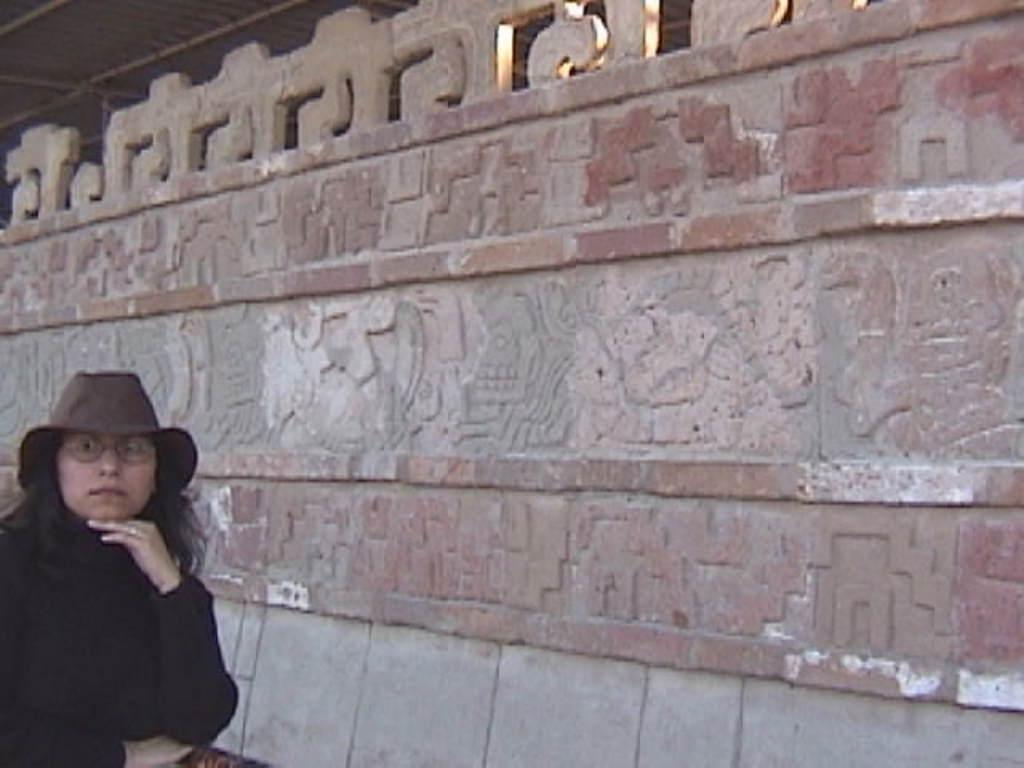Who is present in the image? There is a woman in the image. Where is the woman located in the image? The woman is on the left side of the image. What is the woman wearing on her head? The woman is wearing a hat. What can be seen behind the woman in the image? There is a wall in the image. How is the wall decorated or designed? The wall is carved. How do the dolls show respect to the woman in the image? There are no dolls present in the image, so they cannot show respect to the woman. 